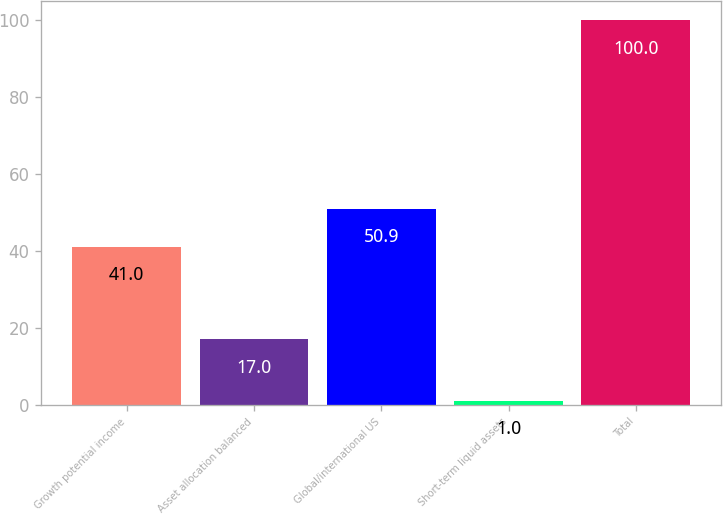<chart> <loc_0><loc_0><loc_500><loc_500><bar_chart><fcel>Growth potential income<fcel>Asset allocation balanced<fcel>Global/international US<fcel>Short-term liquid assets<fcel>Total<nl><fcel>41<fcel>17<fcel>50.9<fcel>1<fcel>100<nl></chart> 